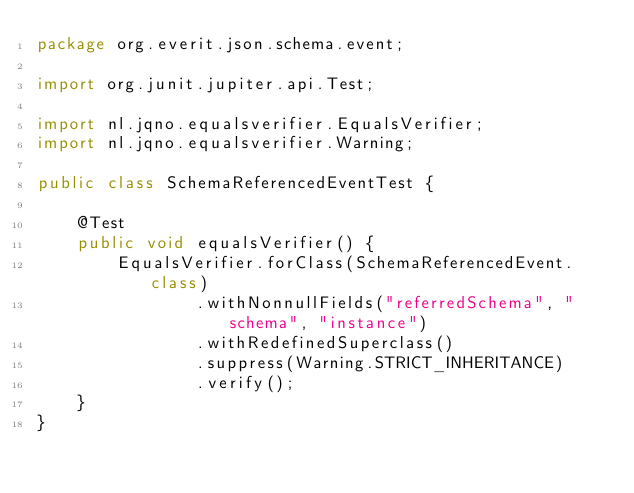Convert code to text. <code><loc_0><loc_0><loc_500><loc_500><_Java_>package org.everit.json.schema.event;

import org.junit.jupiter.api.Test;

import nl.jqno.equalsverifier.EqualsVerifier;
import nl.jqno.equalsverifier.Warning;

public class SchemaReferencedEventTest {

    @Test
    public void equalsVerifier() {
        EqualsVerifier.forClass(SchemaReferencedEvent.class)
                .withNonnullFields("referredSchema", "schema", "instance")
                .withRedefinedSuperclass()
                .suppress(Warning.STRICT_INHERITANCE)
                .verify();
    }
}
</code> 